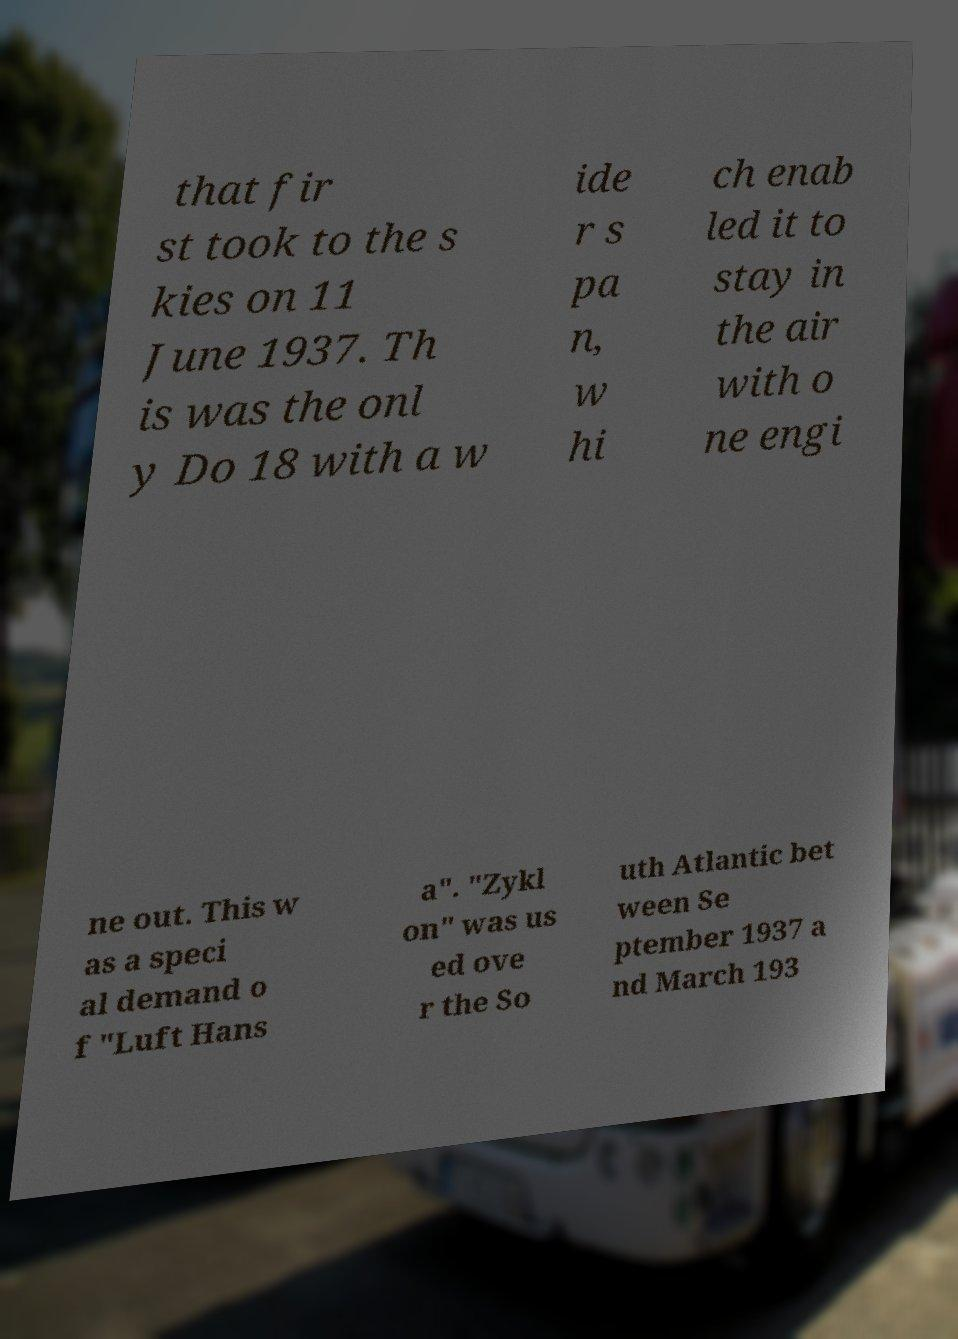I need the written content from this picture converted into text. Can you do that? that fir st took to the s kies on 11 June 1937. Th is was the onl y Do 18 with a w ide r s pa n, w hi ch enab led it to stay in the air with o ne engi ne out. This w as a speci al demand o f "Luft Hans a". "Zykl on" was us ed ove r the So uth Atlantic bet ween Se ptember 1937 a nd March 193 